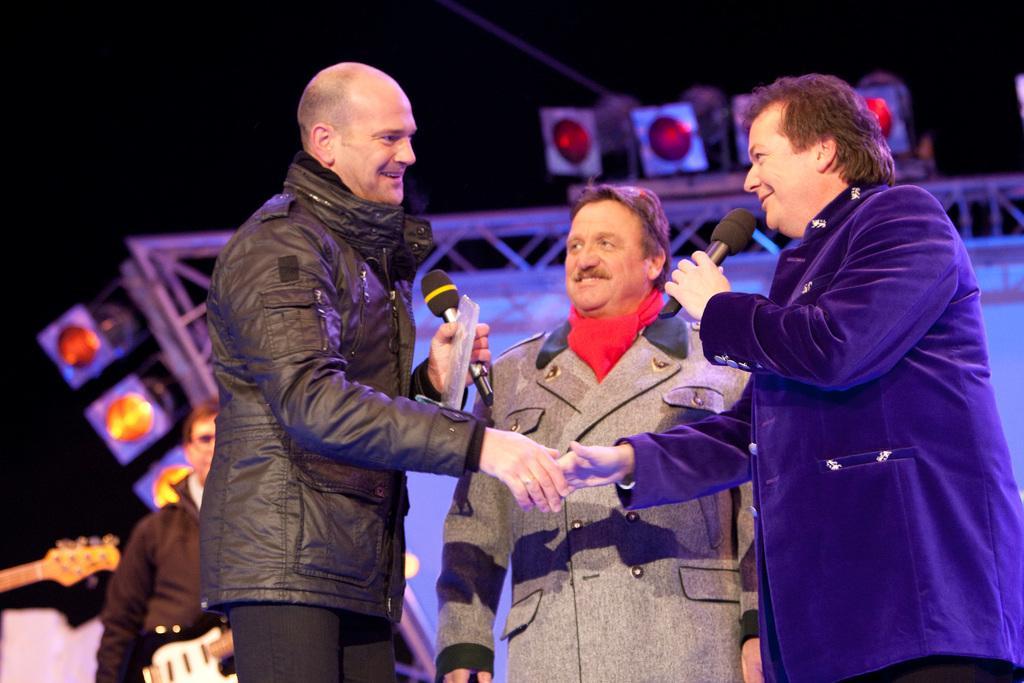Please provide a concise description of this image. In the center of the image there is a person wearing a smile on his face. Beside him there are two other persons holding the miles and they are shaking their hands. Behind them there is another person holding the guitar. In the background of the image there is a banner. There are lights. 